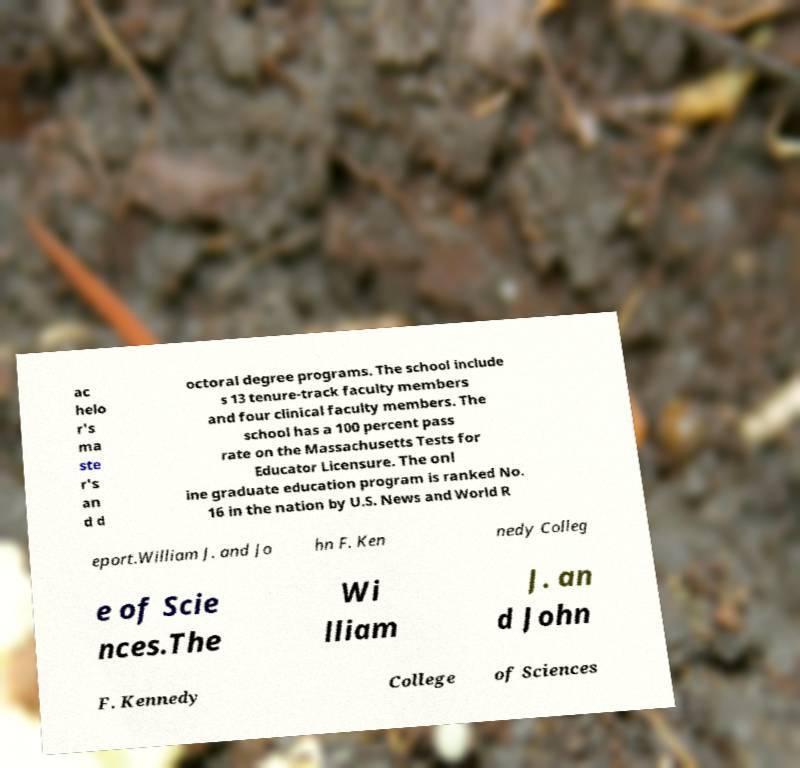Please read and relay the text visible in this image. What does it say? ac helo r's ma ste r's an d d octoral degree programs. The school include s 13 tenure-track faculty members and four clinical faculty members. The school has a 100 percent pass rate on the Massachusetts Tests for Educator Licensure. The onl ine graduate education program is ranked No. 16 in the nation by U.S. News and World R eport.William J. and Jo hn F. Ken nedy Colleg e of Scie nces.The Wi lliam J. an d John F. Kennedy College of Sciences 